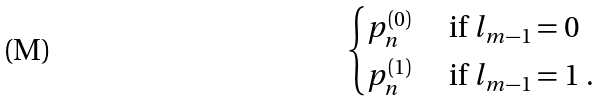Convert formula to latex. <formula><loc_0><loc_0><loc_500><loc_500>\begin{cases} p _ { n } ^ { ( 0 ) } & \text { if $l_{m-1}=0$ } \\ p _ { n } ^ { ( 1 ) } & \text { if $l_{m-1}=1$ } . \end{cases}</formula> 